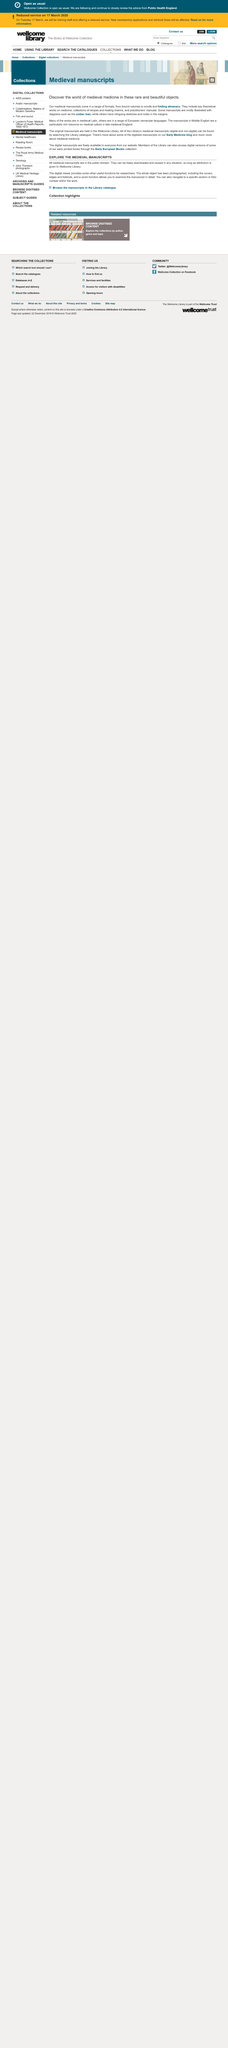Specify some key components in this picture. Yes, scrolls were a part of the range of formats used for medieval manuscripts. Medieval manuscripts are available for public viewing as they are in the public domain and can be freely downloaded through digital viewers, offering additional viewing functions. Yes, the covers of medieval manuscripts are available and have been photographed as part of the entire object. Yes, it is. Yes, medieval manuscripts can be reused because they are in the public domain. 